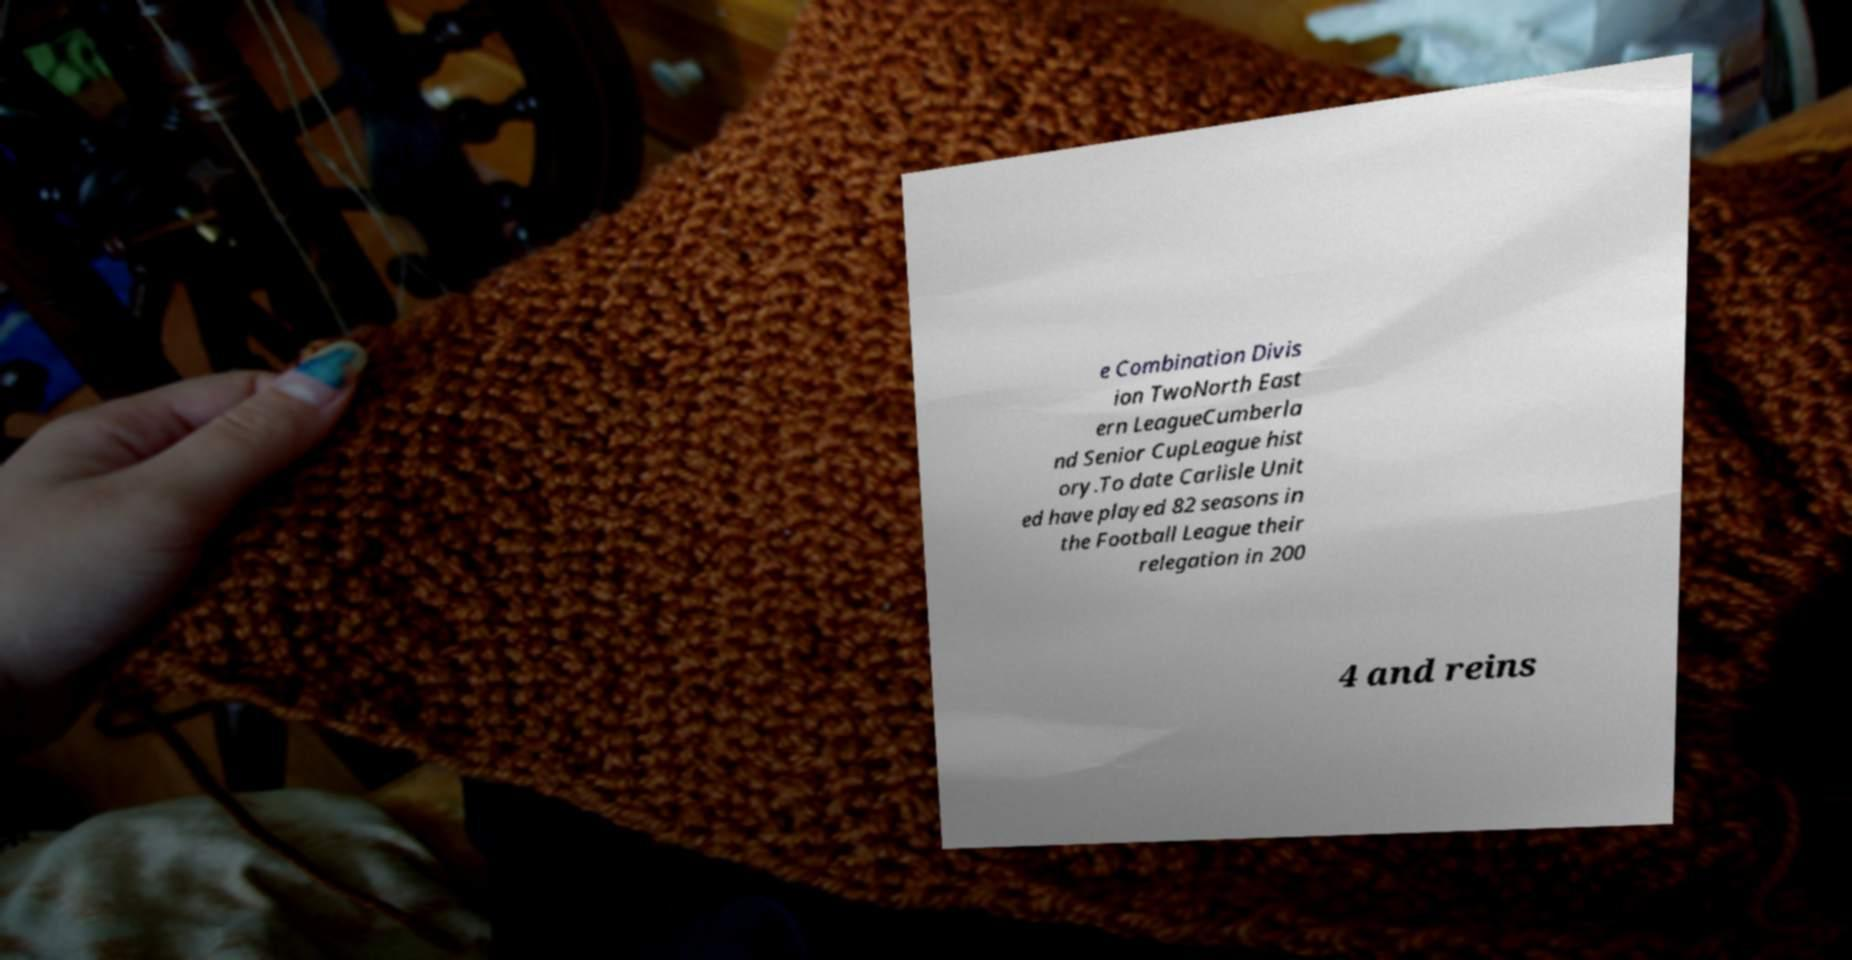For documentation purposes, I need the text within this image transcribed. Could you provide that? e Combination Divis ion TwoNorth East ern LeagueCumberla nd Senior CupLeague hist ory.To date Carlisle Unit ed have played 82 seasons in the Football League their relegation in 200 4 and reins 